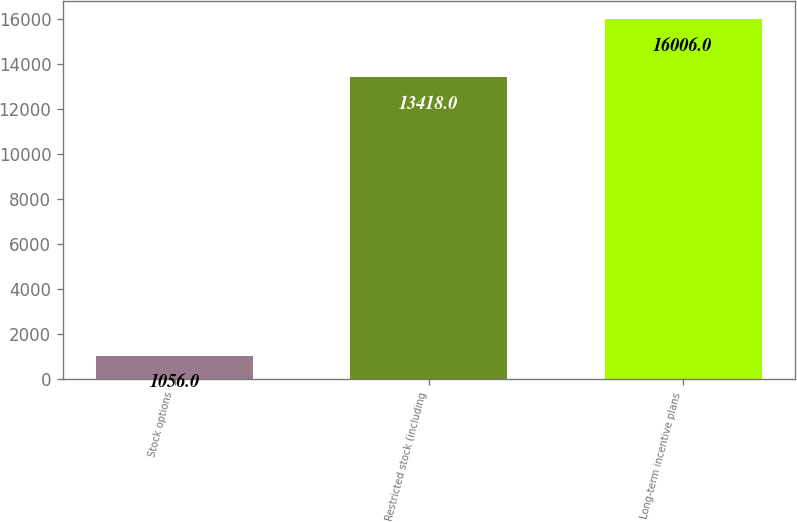Convert chart to OTSL. <chart><loc_0><loc_0><loc_500><loc_500><bar_chart><fcel>Stock options<fcel>Restricted stock (including<fcel>Long-term incentive plans<nl><fcel>1056<fcel>13418<fcel>16006<nl></chart> 